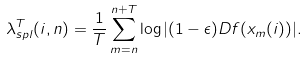<formula> <loc_0><loc_0><loc_500><loc_500>\lambda _ { s p l } ^ { T } ( i , n ) = \frac { 1 } { T } \sum _ { m = n } ^ { n + T } \log | ( 1 - \epsilon ) D f ( x _ { m } ( i ) ) | .</formula> 